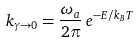<formula> <loc_0><loc_0><loc_500><loc_500>k _ { \gamma \rightarrow 0 } = \frac { \omega _ { a } } { 2 \pi } \, e ^ { - E / k _ { B } T }</formula> 